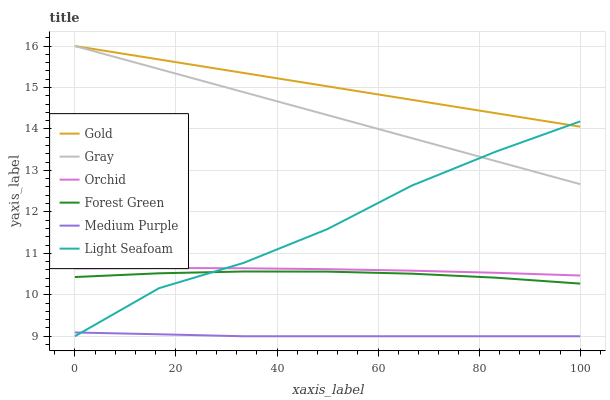Does Medium Purple have the minimum area under the curve?
Answer yes or no. Yes. Does Gold have the maximum area under the curve?
Answer yes or no. Yes. Does Gold have the minimum area under the curve?
Answer yes or no. No. Does Medium Purple have the maximum area under the curve?
Answer yes or no. No. Is Gold the smoothest?
Answer yes or no. Yes. Is Light Seafoam the roughest?
Answer yes or no. Yes. Is Medium Purple the smoothest?
Answer yes or no. No. Is Medium Purple the roughest?
Answer yes or no. No. Does Medium Purple have the lowest value?
Answer yes or no. Yes. Does Gold have the lowest value?
Answer yes or no. No. Does Gold have the highest value?
Answer yes or no. Yes. Does Medium Purple have the highest value?
Answer yes or no. No. Is Orchid less than Gray?
Answer yes or no. Yes. Is Gray greater than Medium Purple?
Answer yes or no. Yes. Does Gold intersect Gray?
Answer yes or no. Yes. Is Gold less than Gray?
Answer yes or no. No. Is Gold greater than Gray?
Answer yes or no. No. Does Orchid intersect Gray?
Answer yes or no. No. 